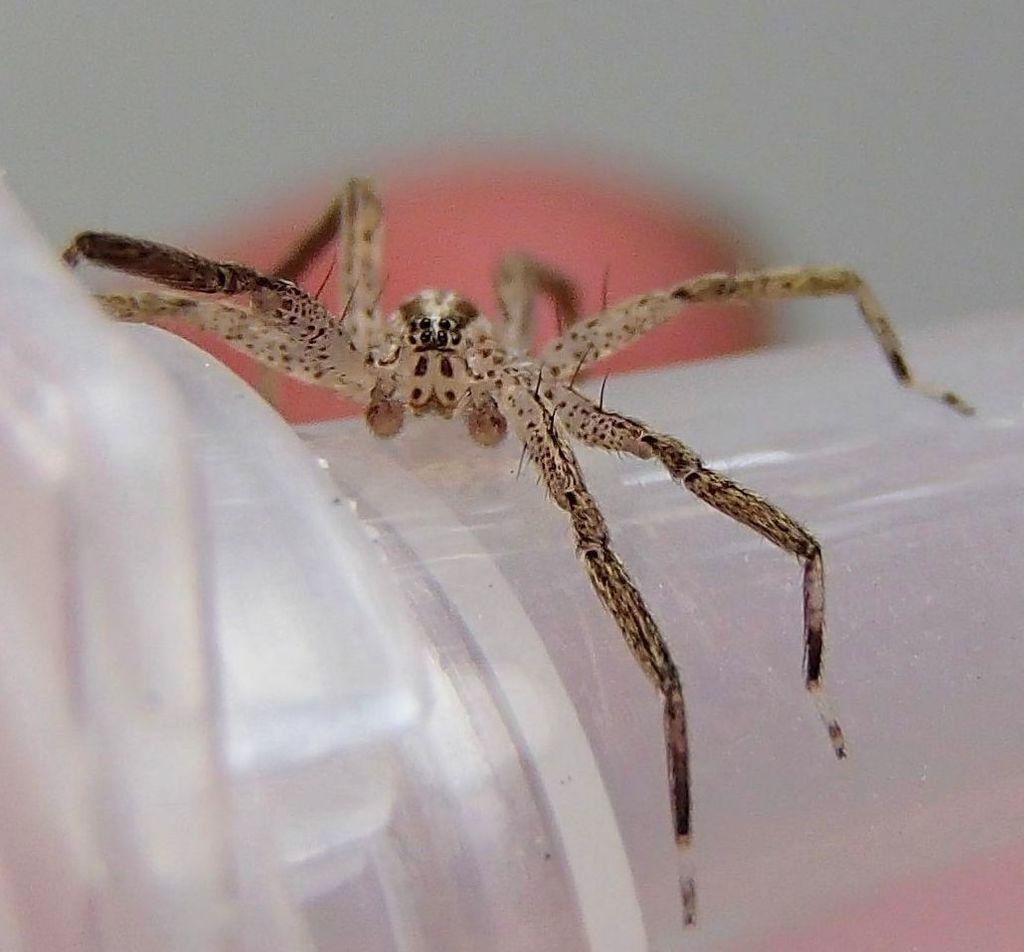Could you give a brief overview of what you see in this image? In this image I can see an insect on an object. And there is a blur background. 